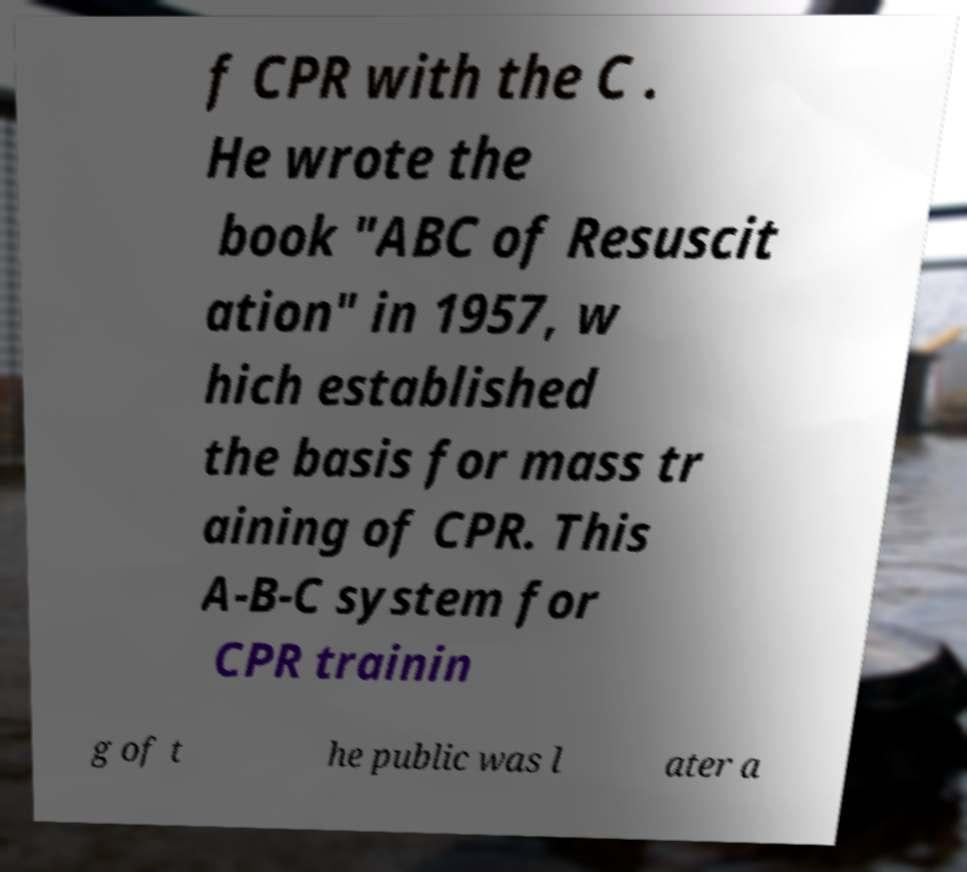Could you assist in decoding the text presented in this image and type it out clearly? f CPR with the C . He wrote the book "ABC of Resuscit ation" in 1957, w hich established the basis for mass tr aining of CPR. This A-B-C system for CPR trainin g of t he public was l ater a 